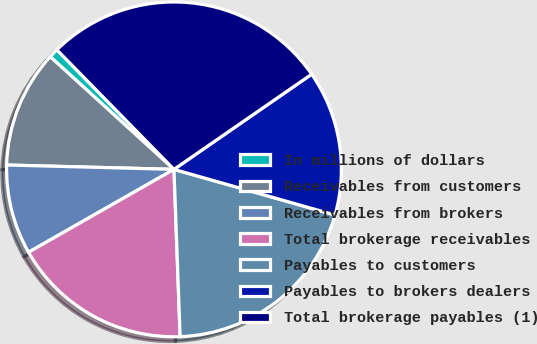Convert chart. <chart><loc_0><loc_0><loc_500><loc_500><pie_chart><fcel>In millions of dollars<fcel>Receivables from customers<fcel>Receivables from brokers<fcel>Total brokerage receivables<fcel>Payables to customers<fcel>Payables to brokers dealers<fcel>Total brokerage payables (1)<nl><fcel>0.91%<fcel>11.34%<fcel>8.66%<fcel>17.34%<fcel>20.02%<fcel>14.02%<fcel>27.71%<nl></chart> 